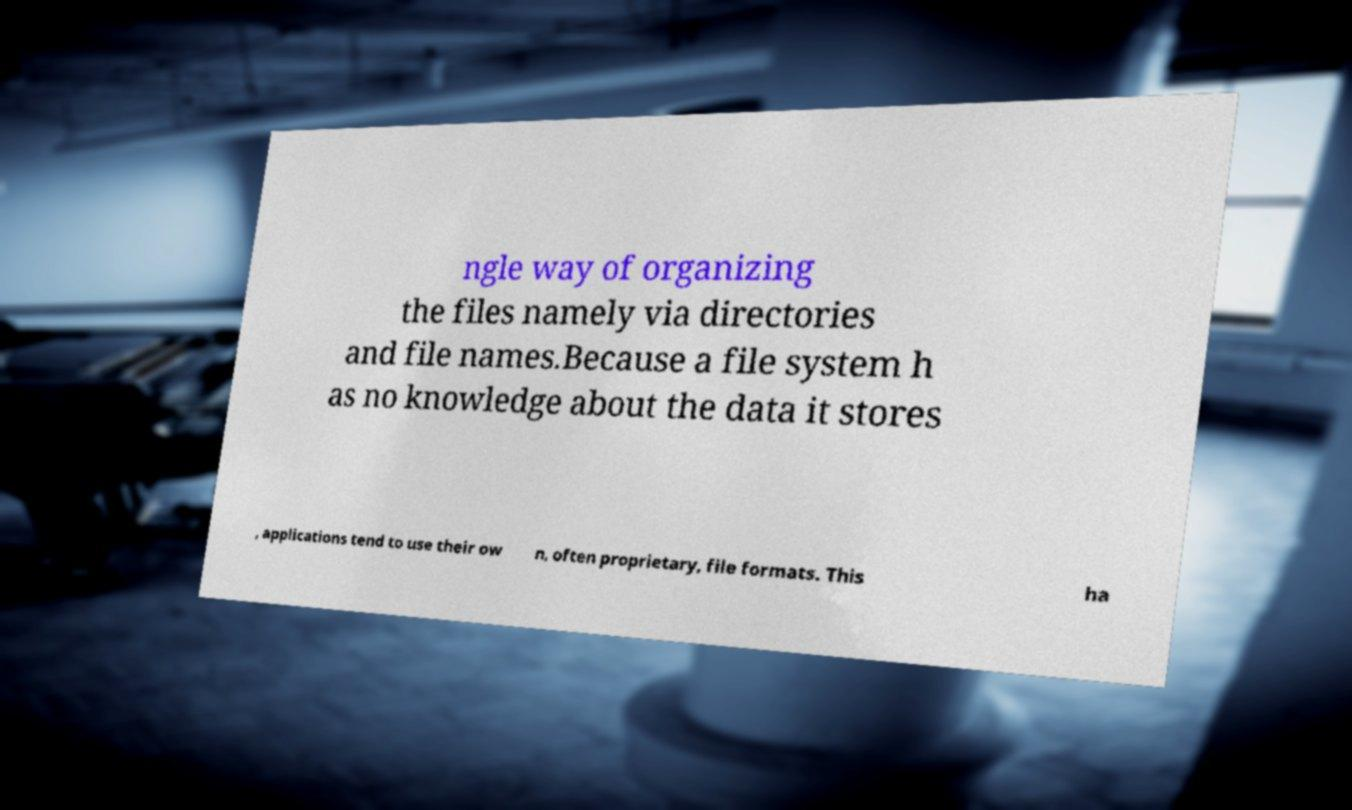Can you accurately transcribe the text from the provided image for me? ngle way of organizing the files namely via directories and file names.Because a file system h as no knowledge about the data it stores , applications tend to use their ow n, often proprietary, file formats. This ha 